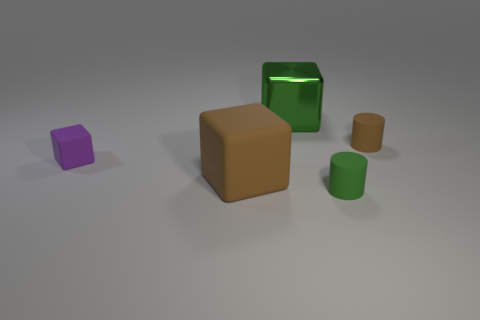What number of tiny blue metal things are there?
Ensure brevity in your answer.  0. How many big matte cubes are the same color as the big metallic object?
Your response must be concise. 0. Do the small object in front of the big brown matte object and the brown matte thing that is in front of the tiny block have the same shape?
Provide a short and direct response. No. The big thing behind the matte cylinder behind the tiny purple block behind the tiny green thing is what color?
Keep it short and to the point. Green. What color is the thing behind the brown cylinder?
Offer a very short reply. Green. What is the color of the other metal block that is the same size as the brown cube?
Keep it short and to the point. Green. Is the size of the brown block the same as the purple object?
Your answer should be compact. No. What number of shiny things are behind the green matte cylinder?
Offer a very short reply. 1. How many objects are rubber cubes in front of the tiny purple cube or cubes?
Offer a terse response. 3. Is the number of purple blocks in front of the tiny matte cube greater than the number of tiny matte cylinders that are behind the big green thing?
Your answer should be very brief. No. 